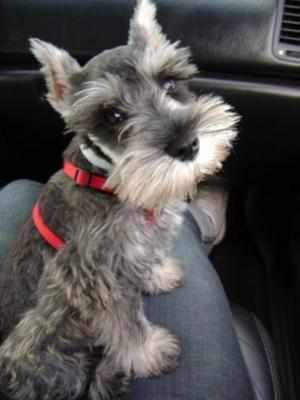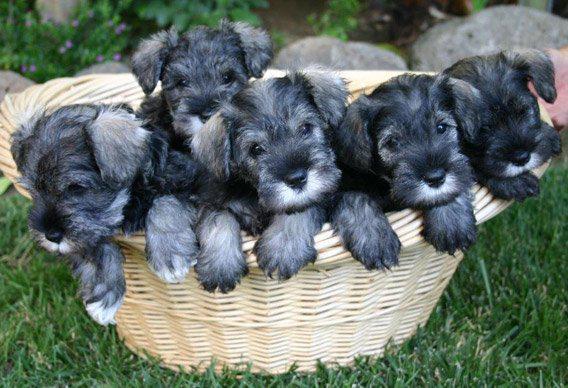The first image is the image on the left, the second image is the image on the right. Assess this claim about the two images: "One of the dogs is on a sidewalk near the grass.". Correct or not? Answer yes or no. No. The first image is the image on the left, the second image is the image on the right. For the images displayed, is the sentence "Left image features a schnauzer dog sitting inside a car on a seat." factually correct? Answer yes or no. Yes. 